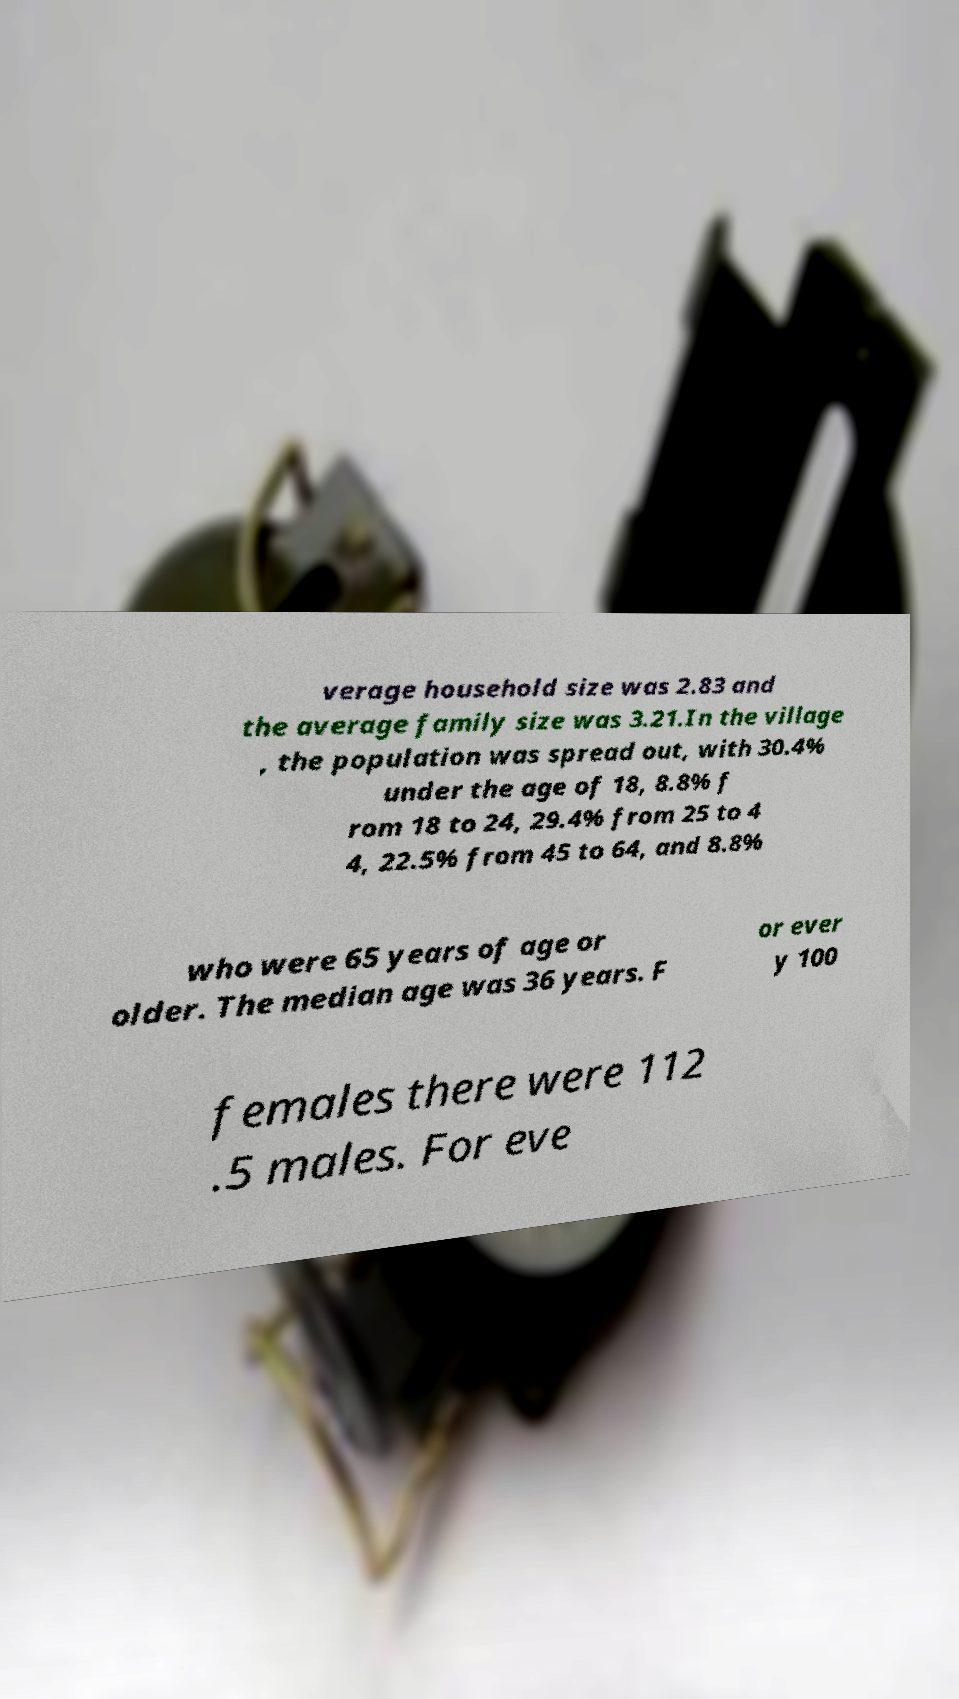I need the written content from this picture converted into text. Can you do that? verage household size was 2.83 and the average family size was 3.21.In the village , the population was spread out, with 30.4% under the age of 18, 8.8% f rom 18 to 24, 29.4% from 25 to 4 4, 22.5% from 45 to 64, and 8.8% who were 65 years of age or older. The median age was 36 years. F or ever y 100 females there were 112 .5 males. For eve 